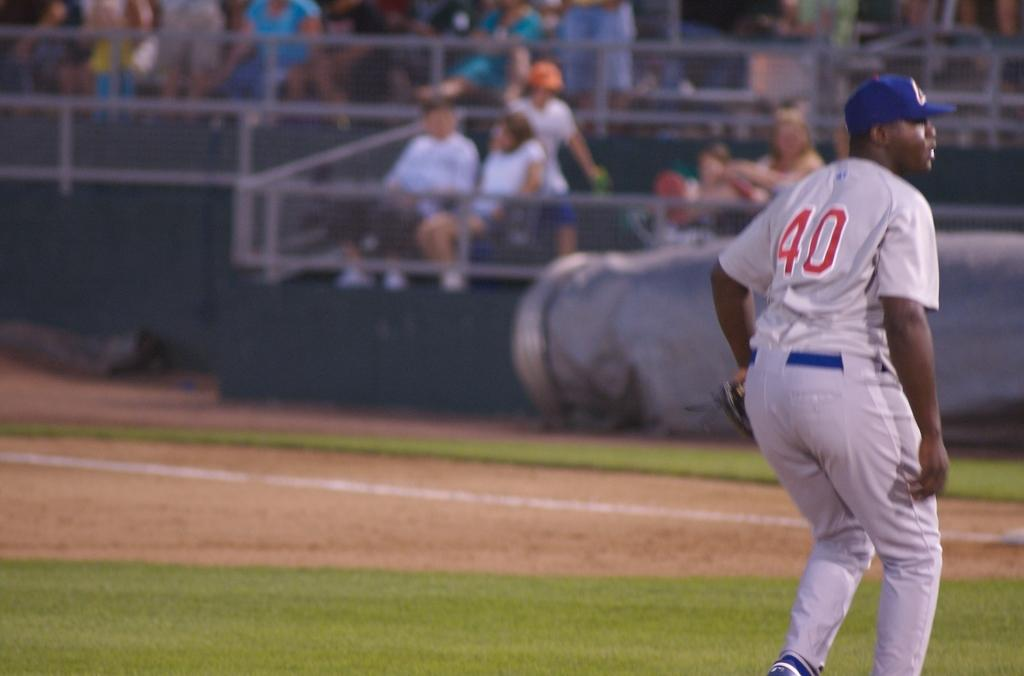Provide a one-sentence caption for the provided image. a baseball player in a grey uniform with the number 40 on it. 